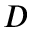Convert formula to latex. <formula><loc_0><loc_0><loc_500><loc_500>D</formula> 